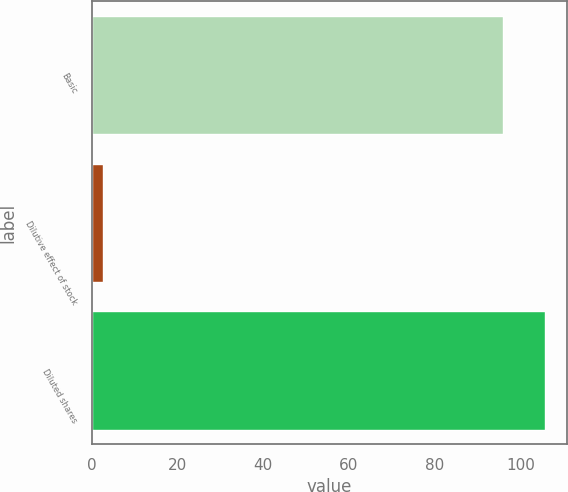Convert chart to OTSL. <chart><loc_0><loc_0><loc_500><loc_500><bar_chart><fcel>Basic<fcel>Dilutive effect of stock<fcel>Diluted shares<nl><fcel>96<fcel>2.7<fcel>105.6<nl></chart> 